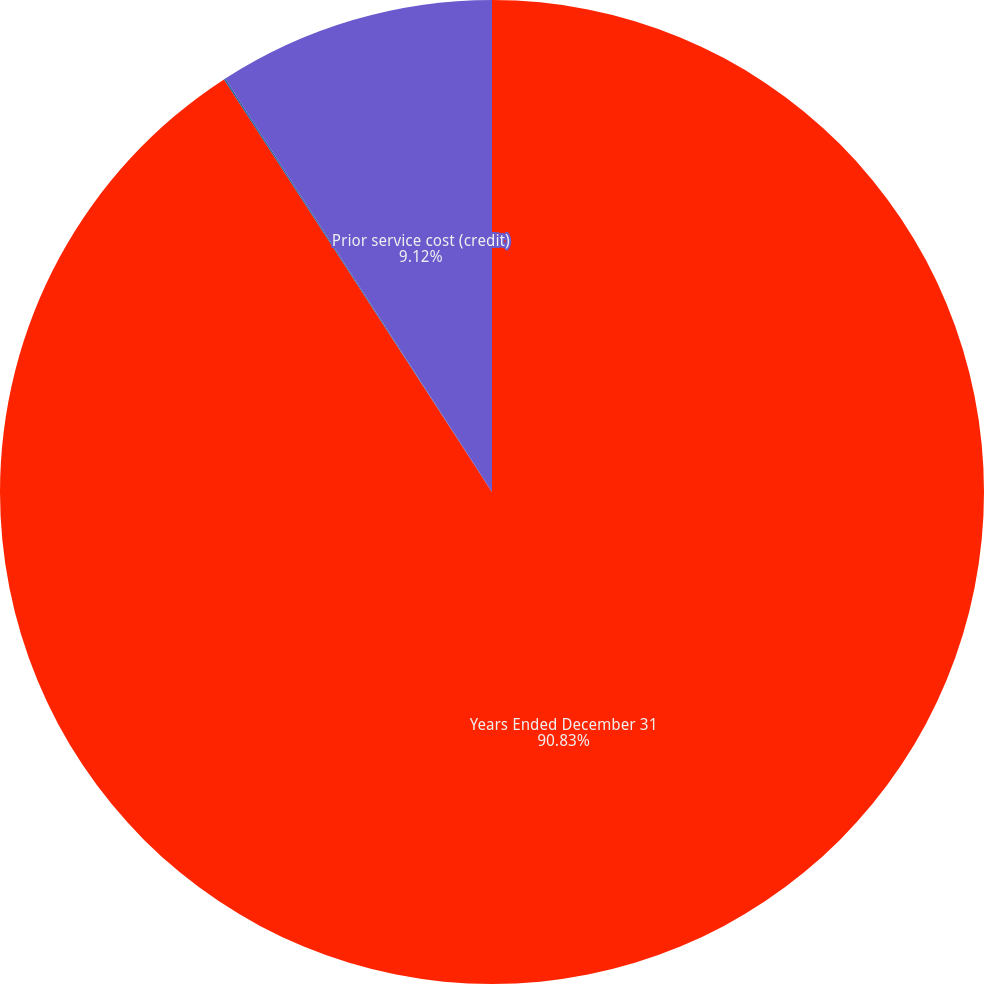<chart> <loc_0><loc_0><loc_500><loc_500><pie_chart><fcel>Years Ended December 31<fcel>Prior service credit (cost)<fcel>Prior service cost (credit)<nl><fcel>90.83%<fcel>0.05%<fcel>9.12%<nl></chart> 